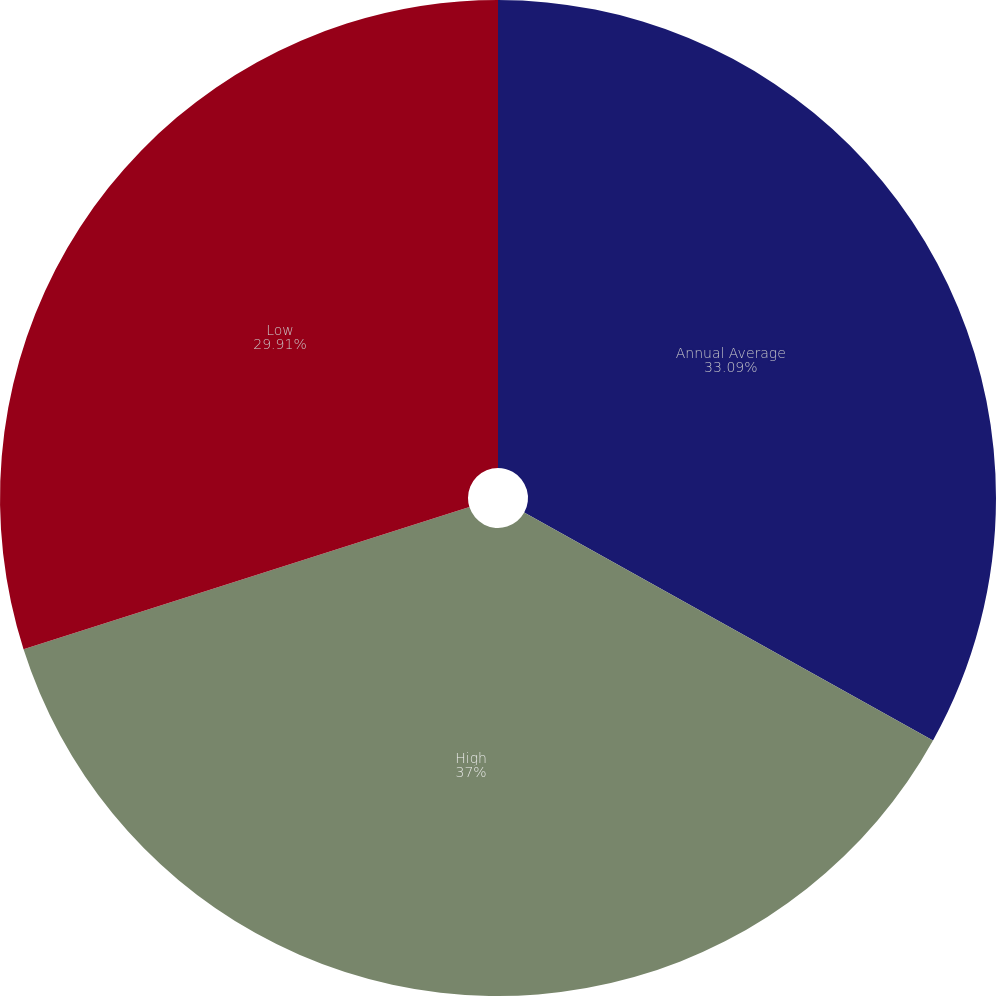<chart> <loc_0><loc_0><loc_500><loc_500><pie_chart><fcel>Annual Average<fcel>High<fcel>Low<nl><fcel>33.09%<fcel>36.99%<fcel>29.91%<nl></chart> 